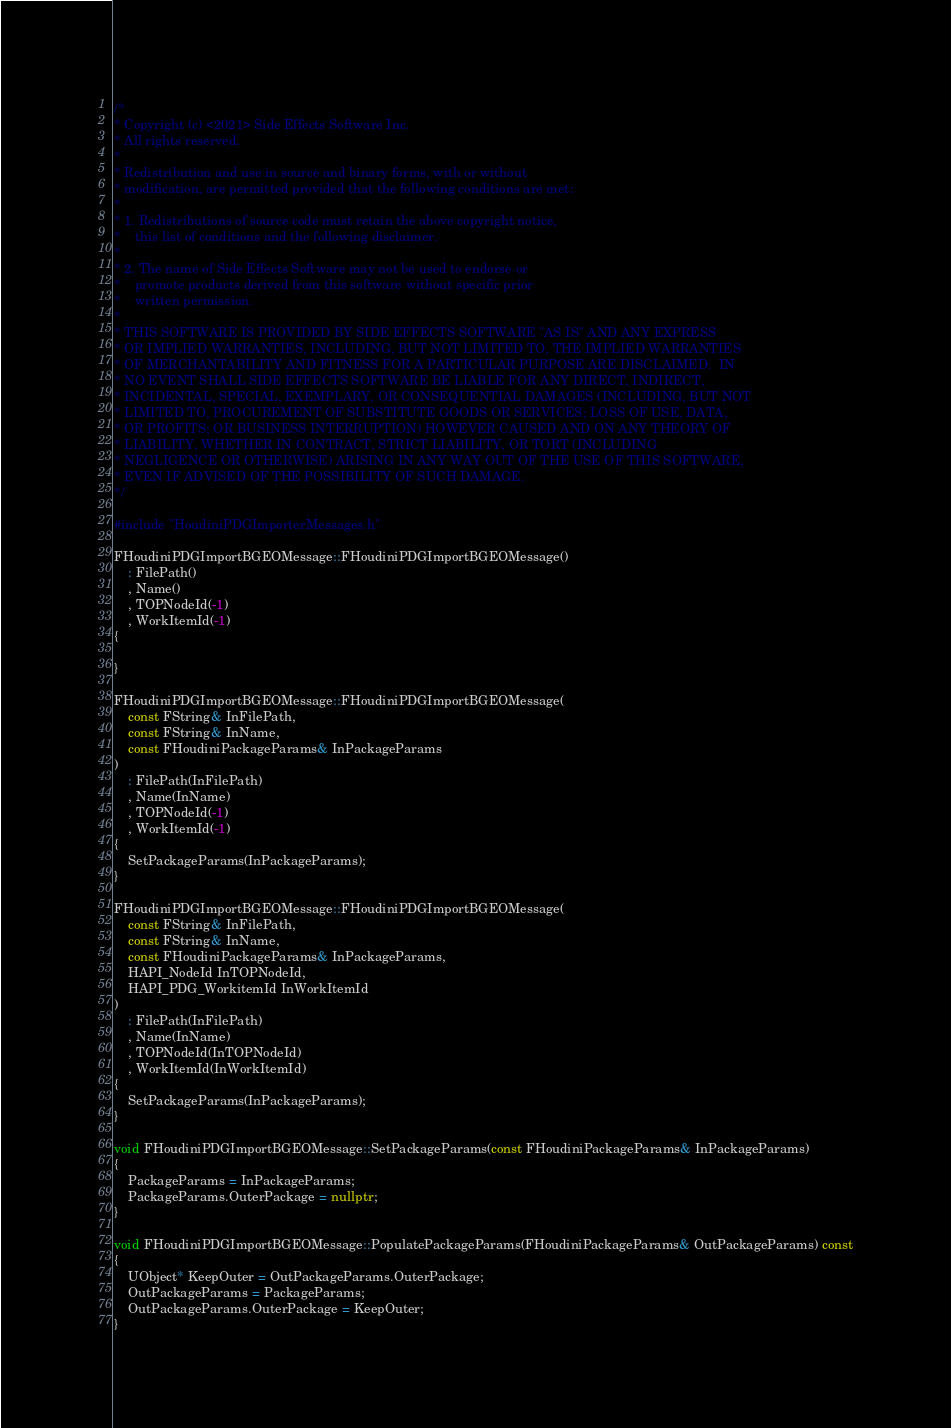Convert code to text. <code><loc_0><loc_0><loc_500><loc_500><_C++_>/*
* Copyright (c) <2021> Side Effects Software Inc.
* All rights reserved.
*
* Redistribution and use in source and binary forms, with or without
* modification, are permitted provided that the following conditions are met:
*
* 1. Redistributions of source code must retain the above copyright notice,
*    this list of conditions and the following disclaimer.
*
* 2. The name of Side Effects Software may not be used to endorse or
*    promote products derived from this software without specific prior
*    written permission.
*
* THIS SOFTWARE IS PROVIDED BY SIDE EFFECTS SOFTWARE "AS IS" AND ANY EXPRESS
* OR IMPLIED WARRANTIES, INCLUDING, BUT NOT LIMITED TO, THE IMPLIED WARRANTIES
* OF MERCHANTABILITY AND FITNESS FOR A PARTICULAR PURPOSE ARE DISCLAIMED.  IN
* NO EVENT SHALL SIDE EFFECTS SOFTWARE BE LIABLE FOR ANY DIRECT, INDIRECT,
* INCIDENTAL, SPECIAL, EXEMPLARY, OR CONSEQUENTIAL DAMAGES (INCLUDING, BUT NOT
* LIMITED TO, PROCUREMENT OF SUBSTITUTE GOODS OR SERVICES; LOSS OF USE, DATA,
* OR PROFITS; OR BUSINESS INTERRUPTION) HOWEVER CAUSED AND ON ANY THEORY OF
* LIABILITY, WHETHER IN CONTRACT, STRICT LIABILITY, OR TORT (INCLUDING
* NEGLIGENCE OR OTHERWISE) ARISING IN ANY WAY OUT OF THE USE OF THIS SOFTWARE,
* EVEN IF ADVISED OF THE POSSIBILITY OF SUCH DAMAGE.
*/

#include "HoudiniPDGImporterMessages.h"

FHoudiniPDGImportBGEOMessage::FHoudiniPDGImportBGEOMessage()
	: FilePath()
	, Name()
	, TOPNodeId(-1)
	, WorkItemId(-1)
{

}

FHoudiniPDGImportBGEOMessage::FHoudiniPDGImportBGEOMessage(
	const FString& InFilePath, 
	const FString& InName, 
	const FHoudiniPackageParams& InPackageParams
)
	: FilePath(InFilePath)
	, Name(InName)
	, TOPNodeId(-1)
	, WorkItemId(-1)
{
	SetPackageParams(InPackageParams);
}

FHoudiniPDGImportBGEOMessage::FHoudiniPDGImportBGEOMessage(
	const FString& InFilePath,
	const FString& InName,
	const FHoudiniPackageParams& InPackageParams,
	HAPI_NodeId InTOPNodeId,
	HAPI_PDG_WorkitemId InWorkItemId
)
	: FilePath(InFilePath)
	, Name(InName)
	, TOPNodeId(InTOPNodeId)
	, WorkItemId(InWorkItemId)
{
	SetPackageParams(InPackageParams);
}

void FHoudiniPDGImportBGEOMessage::SetPackageParams(const FHoudiniPackageParams& InPackageParams)
{
	PackageParams = InPackageParams;
	PackageParams.OuterPackage = nullptr;
}

void FHoudiniPDGImportBGEOMessage::PopulatePackageParams(FHoudiniPackageParams& OutPackageParams) const
{
	UObject* KeepOuter = OutPackageParams.OuterPackage;
	OutPackageParams = PackageParams;
	OutPackageParams.OuterPackage = KeepOuter;
}
</code> 